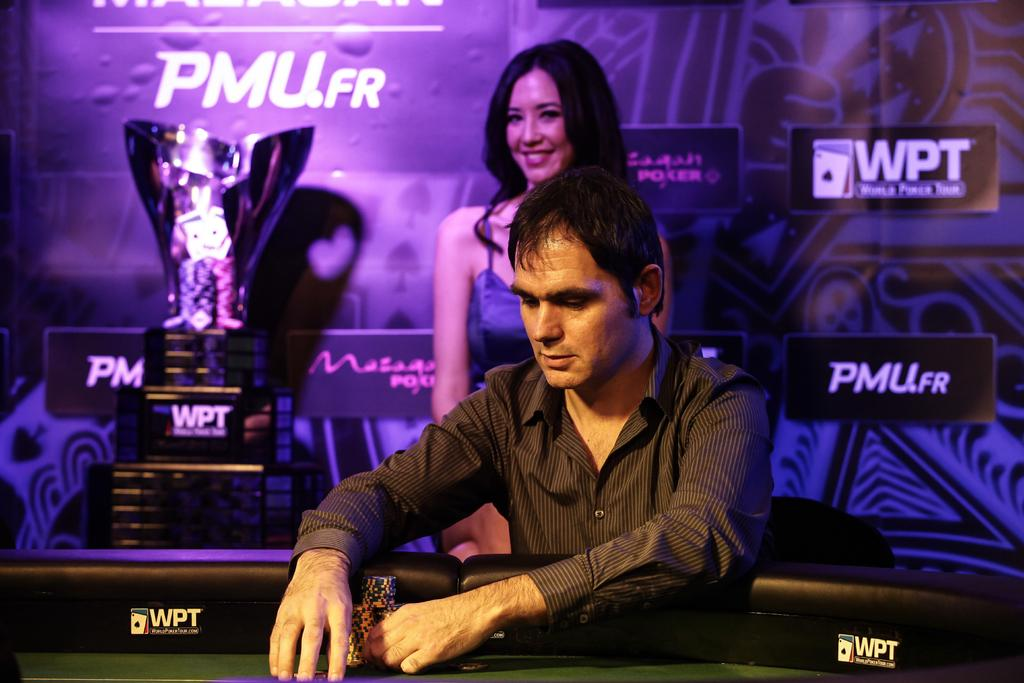<image>
Describe the image concisely. A man handling a stack of poker chips at a table with the letters WPT printed on the inside barrier. 